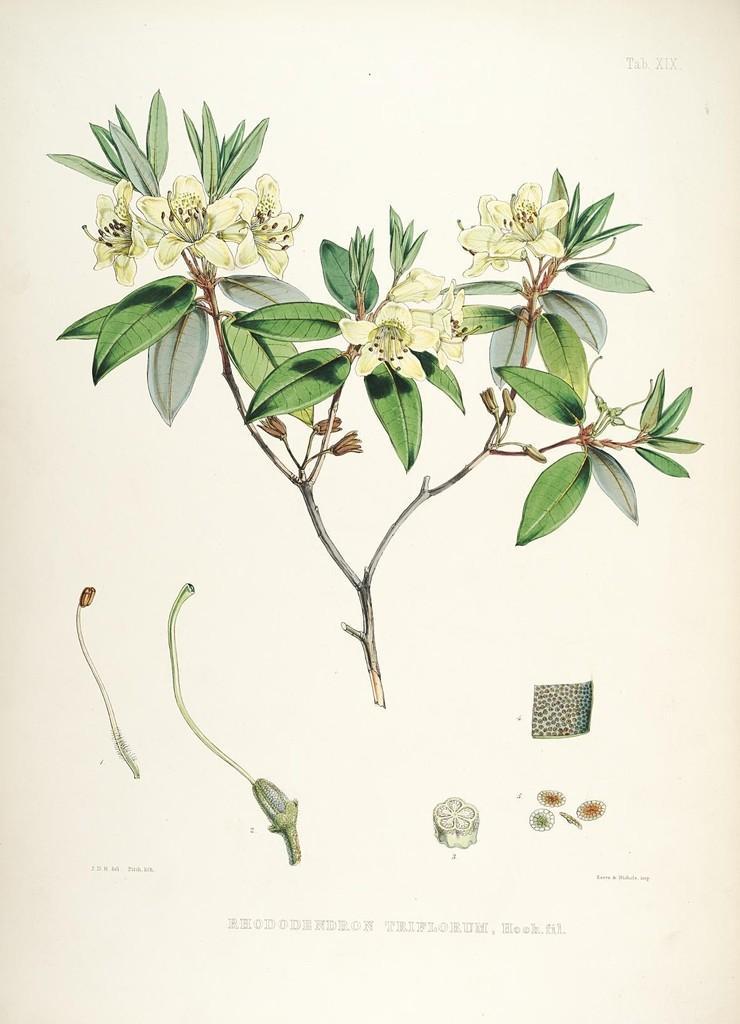Could you give a brief overview of what you see in this image? In this image there is a drawing of the plant and there are parts of the plant. 